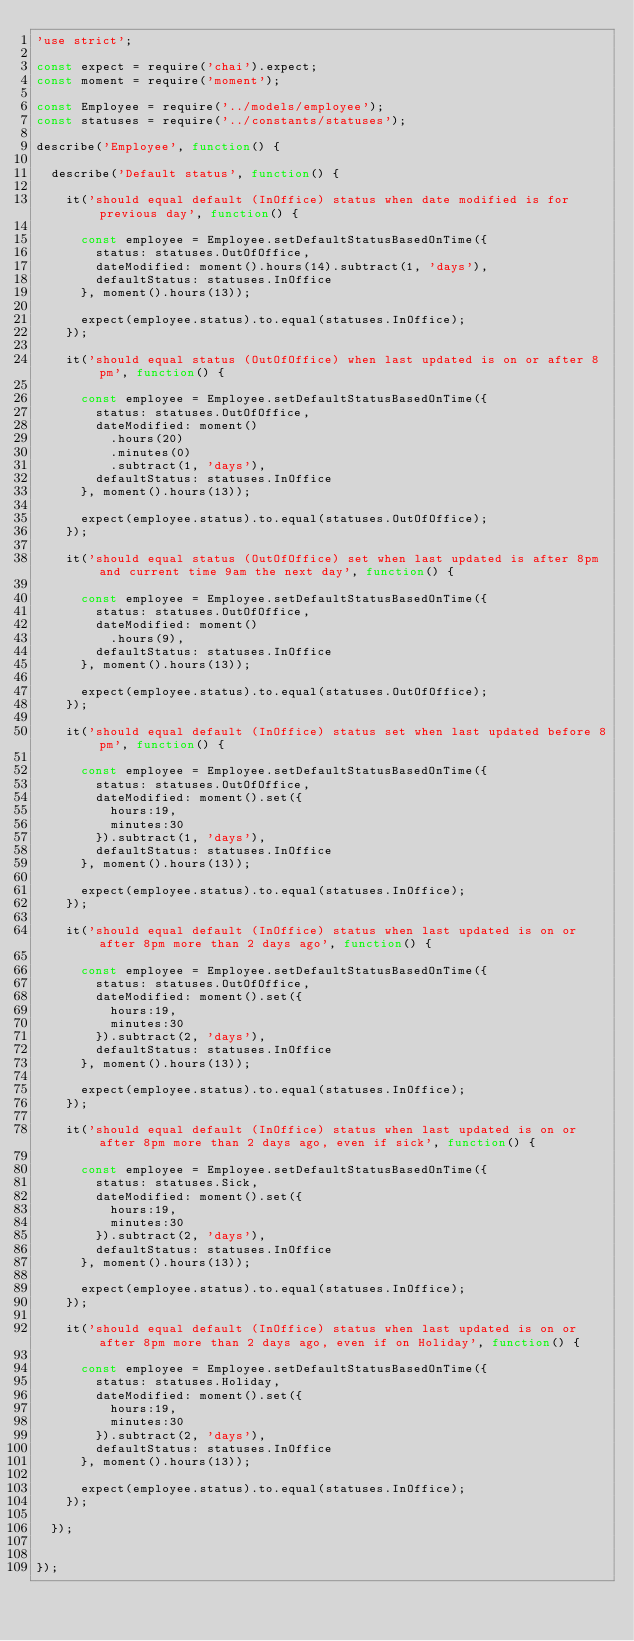<code> <loc_0><loc_0><loc_500><loc_500><_JavaScript_>'use strict';

const expect = require('chai').expect;
const moment = require('moment');

const Employee = require('../models/employee');
const statuses = require('../constants/statuses');

describe('Employee', function() {

  describe('Default status', function() {

    it('should equal default (InOffice) status when date modified is for previous day', function() {

      const employee = Employee.setDefaultStatusBasedOnTime({
        status: statuses.OutOfOffice,
        dateModified: moment().hours(14).subtract(1, 'days'),
        defaultStatus: statuses.InOffice
      }, moment().hours(13));

      expect(employee.status).to.equal(statuses.InOffice);
    });

    it('should equal status (OutOfOffice) when last updated is on or after 8pm', function() {

      const employee = Employee.setDefaultStatusBasedOnTime({
        status: statuses.OutOfOffice,
        dateModified: moment()
          .hours(20)
          .minutes(0)
          .subtract(1, 'days'),
        defaultStatus: statuses.InOffice
      }, moment().hours(13));

      expect(employee.status).to.equal(statuses.OutOfOffice);
    });

    it('should equal status (OutOfOffice) set when last updated is after 8pm and current time 9am the next day', function() {

      const employee = Employee.setDefaultStatusBasedOnTime({
        status: statuses.OutOfOffice,
        dateModified: moment()
          .hours(9),
        defaultStatus: statuses.InOffice
      }, moment().hours(13));

      expect(employee.status).to.equal(statuses.OutOfOffice);
    });

    it('should equal default (InOffice) status set when last updated before 8pm', function() {

      const employee = Employee.setDefaultStatusBasedOnTime({
        status: statuses.OutOfOffice,
        dateModified: moment().set({
          hours:19,
          minutes:30
        }).subtract(1, 'days'),
        defaultStatus: statuses.InOffice
      }, moment().hours(13));

      expect(employee.status).to.equal(statuses.InOffice);
    });

    it('should equal default (InOffice) status when last updated is on or after 8pm more than 2 days ago', function() {

      const employee = Employee.setDefaultStatusBasedOnTime({
        status: statuses.OutOfOffice,
        dateModified: moment().set({
          hours:19,
          minutes:30
        }).subtract(2, 'days'),
        defaultStatus: statuses.InOffice
      }, moment().hours(13));

      expect(employee.status).to.equal(statuses.InOffice);
    });

    it('should equal default (InOffice) status when last updated is on or after 8pm more than 2 days ago, even if sick', function() {

      const employee = Employee.setDefaultStatusBasedOnTime({
        status: statuses.Sick,
        dateModified: moment().set({
          hours:19,
          minutes:30
        }).subtract(2, 'days'),
        defaultStatus: statuses.InOffice
      }, moment().hours(13));

      expect(employee.status).to.equal(statuses.InOffice);
    });

    it('should equal default (InOffice) status when last updated is on or after 8pm more than 2 days ago, even if on Holiday', function() {

      const employee = Employee.setDefaultStatusBasedOnTime({
        status: statuses.Holiday,
        dateModified: moment().set({
          hours:19,
          minutes:30
        }).subtract(2, 'days'),
        defaultStatus: statuses.InOffice
      }, moment().hours(13));

      expect(employee.status).to.equal(statuses.InOffice);
    });

  });


});
</code> 